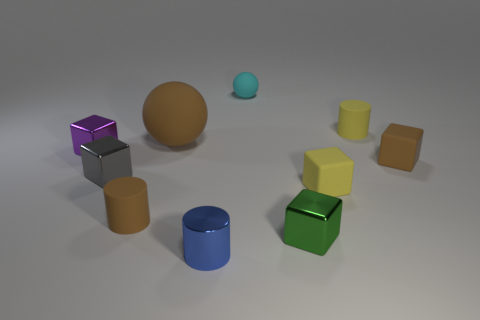Subtract all red cylinders. Subtract all cyan balls. How many cylinders are left? 3 Subtract all balls. How many objects are left? 8 Subtract 1 yellow cylinders. How many objects are left? 9 Subtract all cyan blocks. Subtract all tiny matte blocks. How many objects are left? 8 Add 4 big brown spheres. How many big brown spheres are left? 5 Add 9 cyan matte spheres. How many cyan matte spheres exist? 10 